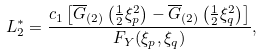<formula> <loc_0><loc_0><loc_500><loc_500>L _ { 2 } ^ { \ast } & = \frac { c _ { 1 } \left [ \overline { G } _ { ( 2 ) } \left ( \frac { 1 } { 2 } \xi _ { p } ^ { 2 } \right ) - \overline { G } _ { ( 2 ) } \left ( \frac { 1 } { 2 } \xi _ { q } ^ { 2 } \right ) \right ] } { F _ { Y } ( \xi _ { p } , \xi _ { q } ) } ,</formula> 